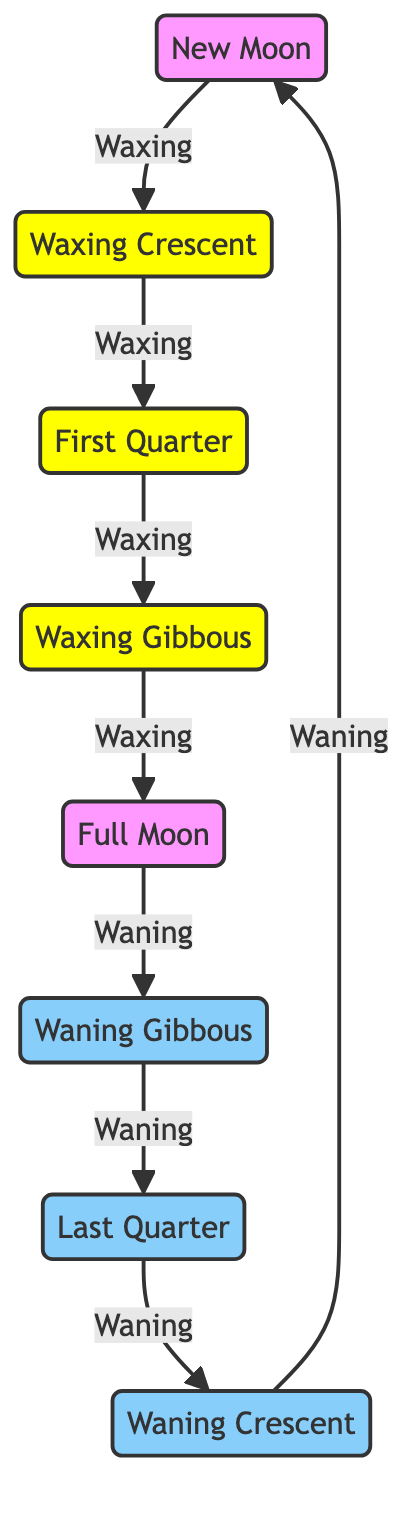What is the first phase of the Moon in the diagram? The diagram starts with the "New Moon" as the first phase. There are directional arrows indicating the flow, and "New Moon" is the first node in the sequence.
Answer: New Moon How many phases of the Moon are represented in the diagram? The diagram shows eight distinct phases of the Moon. By counting each node, we identify New Moon, Waxing Crescent, First Quarter, Waxing Gibbous, Full Moon, Waning Gibbous, Last Quarter, and Waning Crescent.
Answer: Eight What phase comes after the Waxing Gibbous? Following the "Waxing Gibbous" in the flow diagram is the "Full Moon." The directional arrow indicates the progression from one phase to the next.
Answer: Full Moon What is the relationship between the Last Quarter and the Waning Crescent? The relationship shown is sequential; the "Last Quarter" flows into the "Waning Crescent" through an arrow, indicating that the Last Quarter is followed by the Waning Crescent in the lunar cycle.
Answer: Sequential How many nodes represent waxing phases in the diagram? There are four nodes that represent waxing phases: Waxing Crescent, First Quarter, Waxing Gibbous, and Full Moon. By identifying the phases marked as waxing, we can see the total count is four.
Answer: Four What phase occurs immediately before the New Moon? The diagram loops back to the "New Moon" from the "Waning Crescent," indicating that the "Waning Crescent" is the phase before the "New Moon." This cyclical nature is evident in the structure of the diagram.
Answer: Waning Crescent Which phase is directly opposite to the New Moon? The phase directly opposite to the "New Moon" is the "Full Moon." The diagram indicates this relationship as they are connected through the waxing and waning phases.
Answer: Full Moon What type of phases are represented between the New Moon and Full Moon? The phases between the "New Moon" and "Full Moon" are "Waxing" phases, consisting of the "Waxing Crescent," "First Quarter," and "Waxing Gibbous." This labeling is provided in the diagram through color and flow direction.
Answer: Waxing How many waning phases are indicated in the diagram? There are three waning phases depicted: Waning Gibbous, Last Quarter, and Waning Crescent. By identifying the phases labeled as waning, we find the total to be three.
Answer: Three 